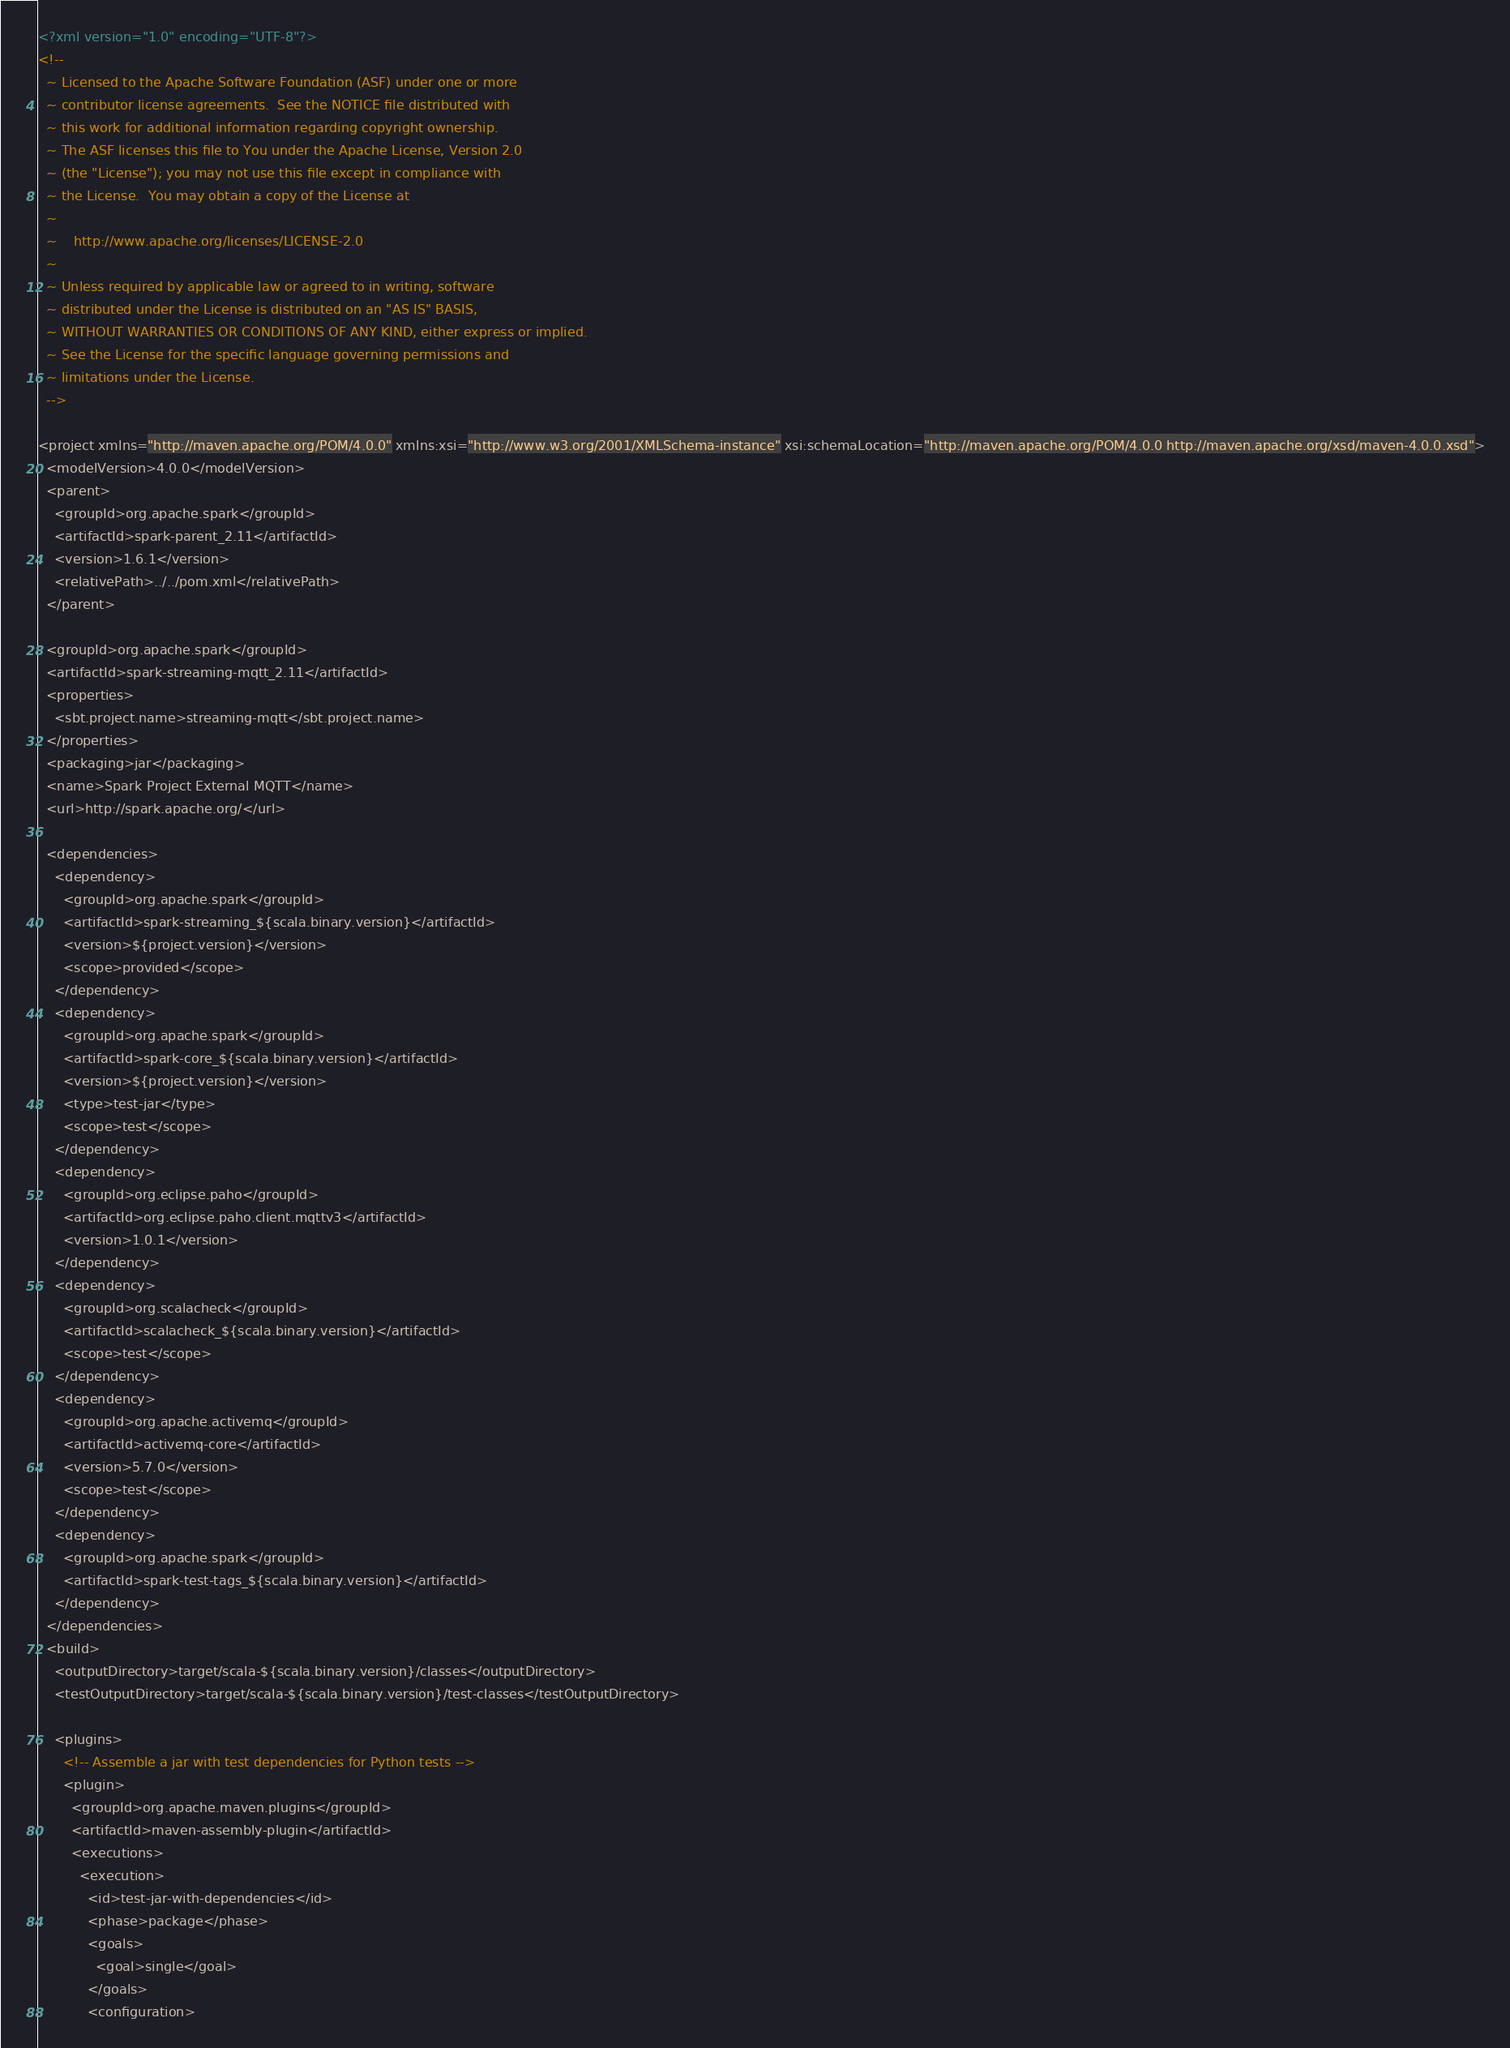<code> <loc_0><loc_0><loc_500><loc_500><_XML_><?xml version="1.0" encoding="UTF-8"?>
<!--
  ~ Licensed to the Apache Software Foundation (ASF) under one or more
  ~ contributor license agreements.  See the NOTICE file distributed with
  ~ this work for additional information regarding copyright ownership.
  ~ The ASF licenses this file to You under the Apache License, Version 2.0
  ~ (the "License"); you may not use this file except in compliance with
  ~ the License.  You may obtain a copy of the License at
  ~
  ~    http://www.apache.org/licenses/LICENSE-2.0
  ~
  ~ Unless required by applicable law or agreed to in writing, software
  ~ distributed under the License is distributed on an "AS IS" BASIS,
  ~ WITHOUT WARRANTIES OR CONDITIONS OF ANY KIND, either express or implied.
  ~ See the License for the specific language governing permissions and
  ~ limitations under the License.
  -->

<project xmlns="http://maven.apache.org/POM/4.0.0" xmlns:xsi="http://www.w3.org/2001/XMLSchema-instance" xsi:schemaLocation="http://maven.apache.org/POM/4.0.0 http://maven.apache.org/xsd/maven-4.0.0.xsd">
  <modelVersion>4.0.0</modelVersion>
  <parent>
    <groupId>org.apache.spark</groupId>
    <artifactId>spark-parent_2.11</artifactId>
    <version>1.6.1</version>
    <relativePath>../../pom.xml</relativePath>
  </parent>

  <groupId>org.apache.spark</groupId>
  <artifactId>spark-streaming-mqtt_2.11</artifactId>
  <properties>
    <sbt.project.name>streaming-mqtt</sbt.project.name>
  </properties>
  <packaging>jar</packaging>
  <name>Spark Project External MQTT</name>
  <url>http://spark.apache.org/</url>

  <dependencies>
    <dependency>
      <groupId>org.apache.spark</groupId>
      <artifactId>spark-streaming_${scala.binary.version}</artifactId>
      <version>${project.version}</version>
      <scope>provided</scope>
    </dependency>
    <dependency>
      <groupId>org.apache.spark</groupId>
      <artifactId>spark-core_${scala.binary.version}</artifactId>
      <version>${project.version}</version>
      <type>test-jar</type>
      <scope>test</scope>
    </dependency>
    <dependency>
      <groupId>org.eclipse.paho</groupId>
      <artifactId>org.eclipse.paho.client.mqttv3</artifactId>
      <version>1.0.1</version>
    </dependency>
    <dependency>
      <groupId>org.scalacheck</groupId>
      <artifactId>scalacheck_${scala.binary.version}</artifactId>
      <scope>test</scope>
    </dependency>
    <dependency>
      <groupId>org.apache.activemq</groupId>
      <artifactId>activemq-core</artifactId>
      <version>5.7.0</version>
      <scope>test</scope>
    </dependency>
    <dependency>
      <groupId>org.apache.spark</groupId>
      <artifactId>spark-test-tags_${scala.binary.version}</artifactId>
    </dependency>
  </dependencies>
  <build>
    <outputDirectory>target/scala-${scala.binary.version}/classes</outputDirectory>
    <testOutputDirectory>target/scala-${scala.binary.version}/test-classes</testOutputDirectory>

    <plugins>
      <!-- Assemble a jar with test dependencies for Python tests -->
      <plugin>
        <groupId>org.apache.maven.plugins</groupId>
        <artifactId>maven-assembly-plugin</artifactId>
        <executions>
          <execution>
            <id>test-jar-with-dependencies</id>
            <phase>package</phase>
            <goals>
              <goal>single</goal>
            </goals>
            <configuration></code> 